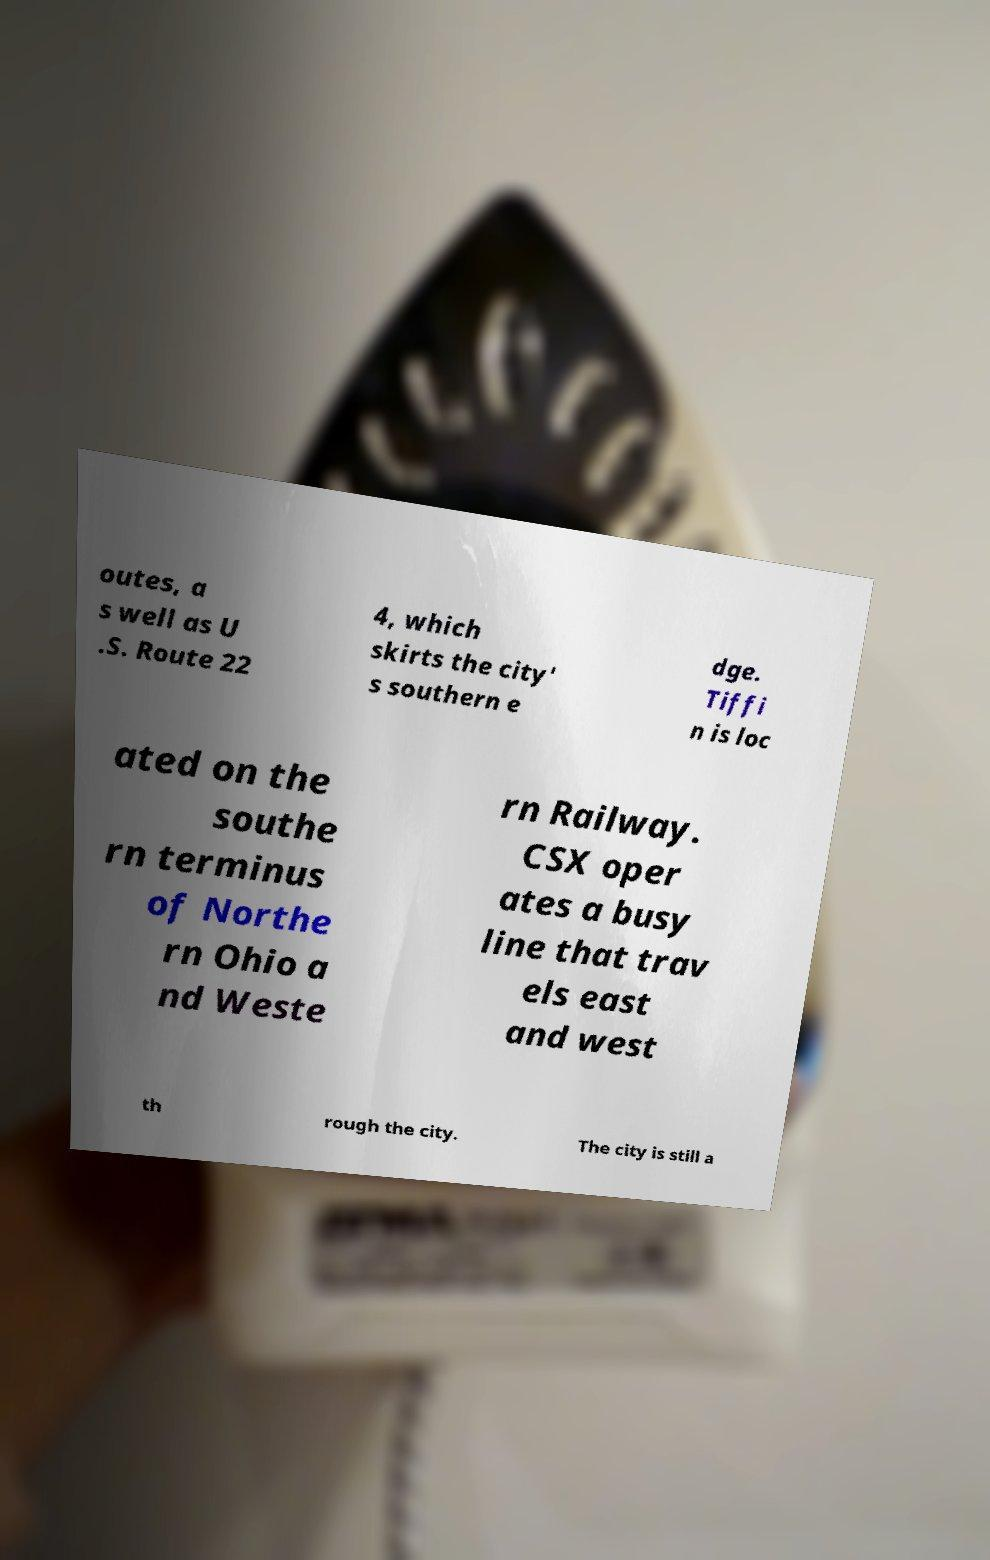Could you extract and type out the text from this image? outes, a s well as U .S. Route 22 4, which skirts the city' s southern e dge. Tiffi n is loc ated on the southe rn terminus of Northe rn Ohio a nd Weste rn Railway. CSX oper ates a busy line that trav els east and west th rough the city. The city is still a 